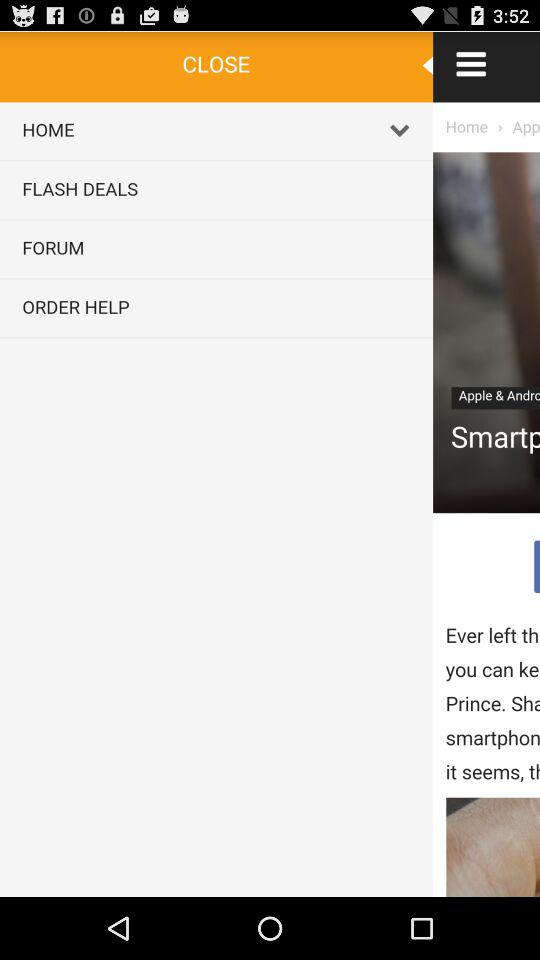What is the currency of the price of different routers? The price is in US dollars. 